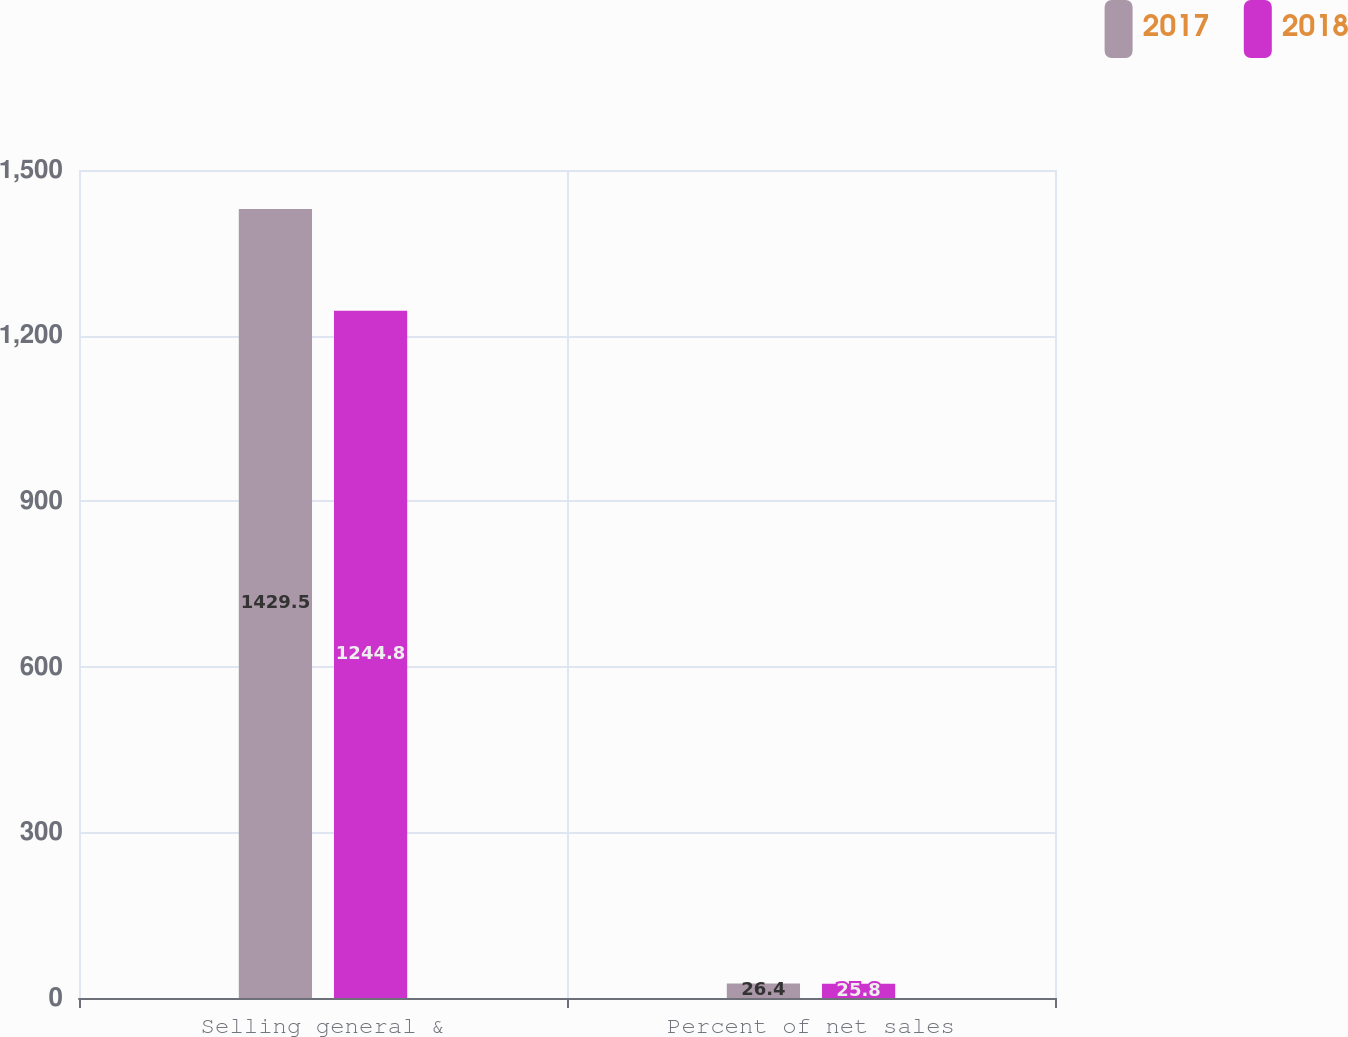<chart> <loc_0><loc_0><loc_500><loc_500><stacked_bar_chart><ecel><fcel>Selling general &<fcel>Percent of net sales<nl><fcel>2017<fcel>1429.5<fcel>26.4<nl><fcel>2018<fcel>1244.8<fcel>25.8<nl></chart> 